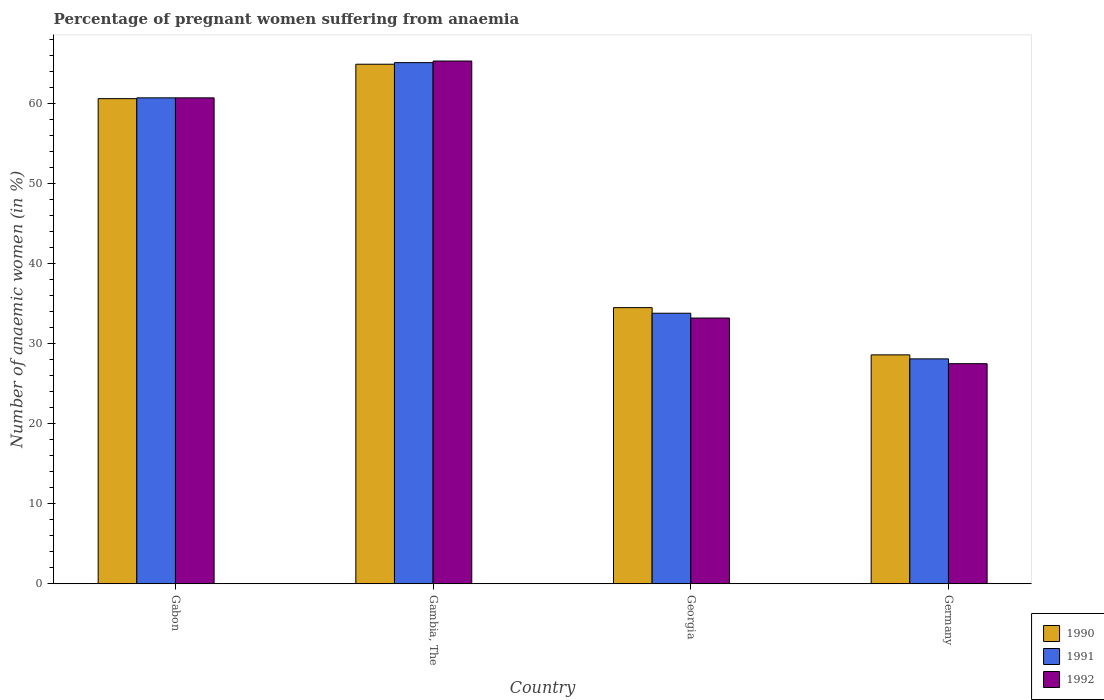How many bars are there on the 1st tick from the left?
Offer a terse response. 3. What is the label of the 1st group of bars from the left?
Ensure brevity in your answer.  Gabon. In how many cases, is the number of bars for a given country not equal to the number of legend labels?
Offer a terse response. 0. What is the number of anaemic women in 1992 in Georgia?
Your answer should be compact. 33.2. Across all countries, what is the maximum number of anaemic women in 1991?
Keep it short and to the point. 65.1. Across all countries, what is the minimum number of anaemic women in 1991?
Offer a very short reply. 28.1. In which country was the number of anaemic women in 1991 maximum?
Provide a short and direct response. Gambia, The. What is the total number of anaemic women in 1992 in the graph?
Your answer should be very brief. 186.7. What is the difference between the number of anaemic women in 1991 in Gabon and that in Germany?
Offer a very short reply. 32.6. What is the difference between the number of anaemic women in 1990 in Georgia and the number of anaemic women in 1992 in Gambia, The?
Offer a very short reply. -30.8. What is the average number of anaemic women in 1990 per country?
Ensure brevity in your answer.  47.15. What is the difference between the number of anaemic women of/in 1991 and number of anaemic women of/in 1990 in Gabon?
Make the answer very short. 0.1. What is the ratio of the number of anaemic women in 1992 in Gabon to that in Gambia, The?
Give a very brief answer. 0.93. Is the difference between the number of anaemic women in 1991 in Gabon and Gambia, The greater than the difference between the number of anaemic women in 1990 in Gabon and Gambia, The?
Your response must be concise. No. What is the difference between the highest and the second highest number of anaemic women in 1992?
Give a very brief answer. 4.6. What is the difference between the highest and the lowest number of anaemic women in 1990?
Your answer should be compact. 36.3. In how many countries, is the number of anaemic women in 1991 greater than the average number of anaemic women in 1991 taken over all countries?
Provide a short and direct response. 2. What does the 1st bar from the left in Gabon represents?
Your response must be concise. 1990. How many bars are there?
Your response must be concise. 12. How many countries are there in the graph?
Your answer should be compact. 4. What is the difference between two consecutive major ticks on the Y-axis?
Provide a succinct answer. 10. Does the graph contain grids?
Make the answer very short. No. How many legend labels are there?
Offer a terse response. 3. What is the title of the graph?
Provide a short and direct response. Percentage of pregnant women suffering from anaemia. Does "2004" appear as one of the legend labels in the graph?
Offer a terse response. No. What is the label or title of the X-axis?
Provide a short and direct response. Country. What is the label or title of the Y-axis?
Make the answer very short. Number of anaemic women (in %). What is the Number of anaemic women (in %) in 1990 in Gabon?
Your answer should be very brief. 60.6. What is the Number of anaemic women (in %) of 1991 in Gabon?
Your response must be concise. 60.7. What is the Number of anaemic women (in %) of 1992 in Gabon?
Keep it short and to the point. 60.7. What is the Number of anaemic women (in %) of 1990 in Gambia, The?
Your answer should be compact. 64.9. What is the Number of anaemic women (in %) in 1991 in Gambia, The?
Offer a terse response. 65.1. What is the Number of anaemic women (in %) of 1992 in Gambia, The?
Ensure brevity in your answer.  65.3. What is the Number of anaemic women (in %) of 1990 in Georgia?
Provide a short and direct response. 34.5. What is the Number of anaemic women (in %) in 1991 in Georgia?
Ensure brevity in your answer.  33.8. What is the Number of anaemic women (in %) in 1992 in Georgia?
Offer a very short reply. 33.2. What is the Number of anaemic women (in %) in 1990 in Germany?
Make the answer very short. 28.6. What is the Number of anaemic women (in %) of 1991 in Germany?
Your answer should be compact. 28.1. Across all countries, what is the maximum Number of anaemic women (in %) of 1990?
Ensure brevity in your answer.  64.9. Across all countries, what is the maximum Number of anaemic women (in %) of 1991?
Make the answer very short. 65.1. Across all countries, what is the maximum Number of anaemic women (in %) of 1992?
Provide a succinct answer. 65.3. Across all countries, what is the minimum Number of anaemic women (in %) in 1990?
Offer a very short reply. 28.6. Across all countries, what is the minimum Number of anaemic women (in %) in 1991?
Offer a very short reply. 28.1. What is the total Number of anaemic women (in %) of 1990 in the graph?
Keep it short and to the point. 188.6. What is the total Number of anaemic women (in %) in 1991 in the graph?
Your answer should be compact. 187.7. What is the total Number of anaemic women (in %) of 1992 in the graph?
Your response must be concise. 186.7. What is the difference between the Number of anaemic women (in %) in 1990 in Gabon and that in Georgia?
Ensure brevity in your answer.  26.1. What is the difference between the Number of anaemic women (in %) in 1991 in Gabon and that in Georgia?
Your answer should be very brief. 26.9. What is the difference between the Number of anaemic women (in %) of 1992 in Gabon and that in Georgia?
Ensure brevity in your answer.  27.5. What is the difference between the Number of anaemic women (in %) in 1991 in Gabon and that in Germany?
Ensure brevity in your answer.  32.6. What is the difference between the Number of anaemic women (in %) of 1992 in Gabon and that in Germany?
Offer a very short reply. 33.2. What is the difference between the Number of anaemic women (in %) in 1990 in Gambia, The and that in Georgia?
Provide a succinct answer. 30.4. What is the difference between the Number of anaemic women (in %) of 1991 in Gambia, The and that in Georgia?
Give a very brief answer. 31.3. What is the difference between the Number of anaemic women (in %) of 1992 in Gambia, The and that in Georgia?
Make the answer very short. 32.1. What is the difference between the Number of anaemic women (in %) of 1990 in Gambia, The and that in Germany?
Offer a very short reply. 36.3. What is the difference between the Number of anaemic women (in %) of 1992 in Gambia, The and that in Germany?
Offer a very short reply. 37.8. What is the difference between the Number of anaemic women (in %) of 1990 in Georgia and that in Germany?
Ensure brevity in your answer.  5.9. What is the difference between the Number of anaemic women (in %) of 1991 in Gabon and the Number of anaemic women (in %) of 1992 in Gambia, The?
Make the answer very short. -4.6. What is the difference between the Number of anaemic women (in %) in 1990 in Gabon and the Number of anaemic women (in %) in 1991 in Georgia?
Provide a short and direct response. 26.8. What is the difference between the Number of anaemic women (in %) in 1990 in Gabon and the Number of anaemic women (in %) in 1992 in Georgia?
Make the answer very short. 27.4. What is the difference between the Number of anaemic women (in %) in 1991 in Gabon and the Number of anaemic women (in %) in 1992 in Georgia?
Offer a very short reply. 27.5. What is the difference between the Number of anaemic women (in %) of 1990 in Gabon and the Number of anaemic women (in %) of 1991 in Germany?
Offer a very short reply. 32.5. What is the difference between the Number of anaemic women (in %) of 1990 in Gabon and the Number of anaemic women (in %) of 1992 in Germany?
Keep it short and to the point. 33.1. What is the difference between the Number of anaemic women (in %) of 1991 in Gabon and the Number of anaemic women (in %) of 1992 in Germany?
Give a very brief answer. 33.2. What is the difference between the Number of anaemic women (in %) of 1990 in Gambia, The and the Number of anaemic women (in %) of 1991 in Georgia?
Your response must be concise. 31.1. What is the difference between the Number of anaemic women (in %) in 1990 in Gambia, The and the Number of anaemic women (in %) in 1992 in Georgia?
Offer a very short reply. 31.7. What is the difference between the Number of anaemic women (in %) in 1991 in Gambia, The and the Number of anaemic women (in %) in 1992 in Georgia?
Your answer should be compact. 31.9. What is the difference between the Number of anaemic women (in %) of 1990 in Gambia, The and the Number of anaemic women (in %) of 1991 in Germany?
Offer a terse response. 36.8. What is the difference between the Number of anaemic women (in %) of 1990 in Gambia, The and the Number of anaemic women (in %) of 1992 in Germany?
Make the answer very short. 37.4. What is the difference between the Number of anaemic women (in %) in 1991 in Gambia, The and the Number of anaemic women (in %) in 1992 in Germany?
Give a very brief answer. 37.6. What is the difference between the Number of anaemic women (in %) in 1990 in Georgia and the Number of anaemic women (in %) in 1991 in Germany?
Give a very brief answer. 6.4. What is the average Number of anaemic women (in %) in 1990 per country?
Your answer should be very brief. 47.15. What is the average Number of anaemic women (in %) of 1991 per country?
Make the answer very short. 46.92. What is the average Number of anaemic women (in %) in 1992 per country?
Your answer should be compact. 46.67. What is the difference between the Number of anaemic women (in %) in 1990 and Number of anaemic women (in %) in 1991 in Gabon?
Offer a very short reply. -0.1. What is the difference between the Number of anaemic women (in %) in 1990 and Number of anaemic women (in %) in 1992 in Georgia?
Offer a terse response. 1.3. What is the difference between the Number of anaemic women (in %) of 1991 and Number of anaemic women (in %) of 1992 in Germany?
Provide a short and direct response. 0.6. What is the ratio of the Number of anaemic women (in %) in 1990 in Gabon to that in Gambia, The?
Provide a short and direct response. 0.93. What is the ratio of the Number of anaemic women (in %) in 1991 in Gabon to that in Gambia, The?
Your response must be concise. 0.93. What is the ratio of the Number of anaemic women (in %) in 1992 in Gabon to that in Gambia, The?
Your answer should be very brief. 0.93. What is the ratio of the Number of anaemic women (in %) of 1990 in Gabon to that in Georgia?
Give a very brief answer. 1.76. What is the ratio of the Number of anaemic women (in %) of 1991 in Gabon to that in Georgia?
Provide a succinct answer. 1.8. What is the ratio of the Number of anaemic women (in %) in 1992 in Gabon to that in Georgia?
Your answer should be compact. 1.83. What is the ratio of the Number of anaemic women (in %) in 1990 in Gabon to that in Germany?
Your response must be concise. 2.12. What is the ratio of the Number of anaemic women (in %) in 1991 in Gabon to that in Germany?
Keep it short and to the point. 2.16. What is the ratio of the Number of anaemic women (in %) in 1992 in Gabon to that in Germany?
Make the answer very short. 2.21. What is the ratio of the Number of anaemic women (in %) of 1990 in Gambia, The to that in Georgia?
Offer a terse response. 1.88. What is the ratio of the Number of anaemic women (in %) in 1991 in Gambia, The to that in Georgia?
Offer a very short reply. 1.93. What is the ratio of the Number of anaemic women (in %) of 1992 in Gambia, The to that in Georgia?
Keep it short and to the point. 1.97. What is the ratio of the Number of anaemic women (in %) of 1990 in Gambia, The to that in Germany?
Keep it short and to the point. 2.27. What is the ratio of the Number of anaemic women (in %) of 1991 in Gambia, The to that in Germany?
Provide a succinct answer. 2.32. What is the ratio of the Number of anaemic women (in %) of 1992 in Gambia, The to that in Germany?
Keep it short and to the point. 2.37. What is the ratio of the Number of anaemic women (in %) of 1990 in Georgia to that in Germany?
Ensure brevity in your answer.  1.21. What is the ratio of the Number of anaemic women (in %) of 1991 in Georgia to that in Germany?
Make the answer very short. 1.2. What is the ratio of the Number of anaemic women (in %) in 1992 in Georgia to that in Germany?
Provide a short and direct response. 1.21. What is the difference between the highest and the second highest Number of anaemic women (in %) in 1990?
Your response must be concise. 4.3. What is the difference between the highest and the second highest Number of anaemic women (in %) of 1991?
Offer a very short reply. 4.4. What is the difference between the highest and the second highest Number of anaemic women (in %) of 1992?
Provide a short and direct response. 4.6. What is the difference between the highest and the lowest Number of anaemic women (in %) in 1990?
Offer a very short reply. 36.3. What is the difference between the highest and the lowest Number of anaemic women (in %) of 1992?
Your response must be concise. 37.8. 